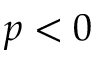<formula> <loc_0><loc_0><loc_500><loc_500>p < 0</formula> 